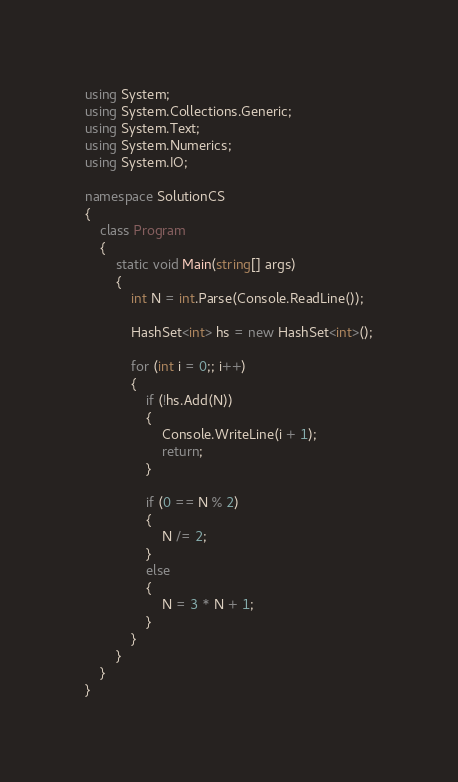Convert code to text. <code><loc_0><loc_0><loc_500><loc_500><_C#_>using System;
using System.Collections.Generic;
using System.Text;
using System.Numerics;
using System.IO;

namespace SolutionCS
{
    class Program
    {
        static void Main(string[] args)
        {
            int N = int.Parse(Console.ReadLine());

            HashSet<int> hs = new HashSet<int>();

            for (int i = 0;; i++)
            {
                if (!hs.Add(N))
                {
                    Console.WriteLine(i + 1);
                    return;
                }

                if (0 == N % 2)
                {
                    N /= 2;
                }
                else
                {
                    N = 3 * N + 1;
                }
            }
        }
    }
}

</code> 